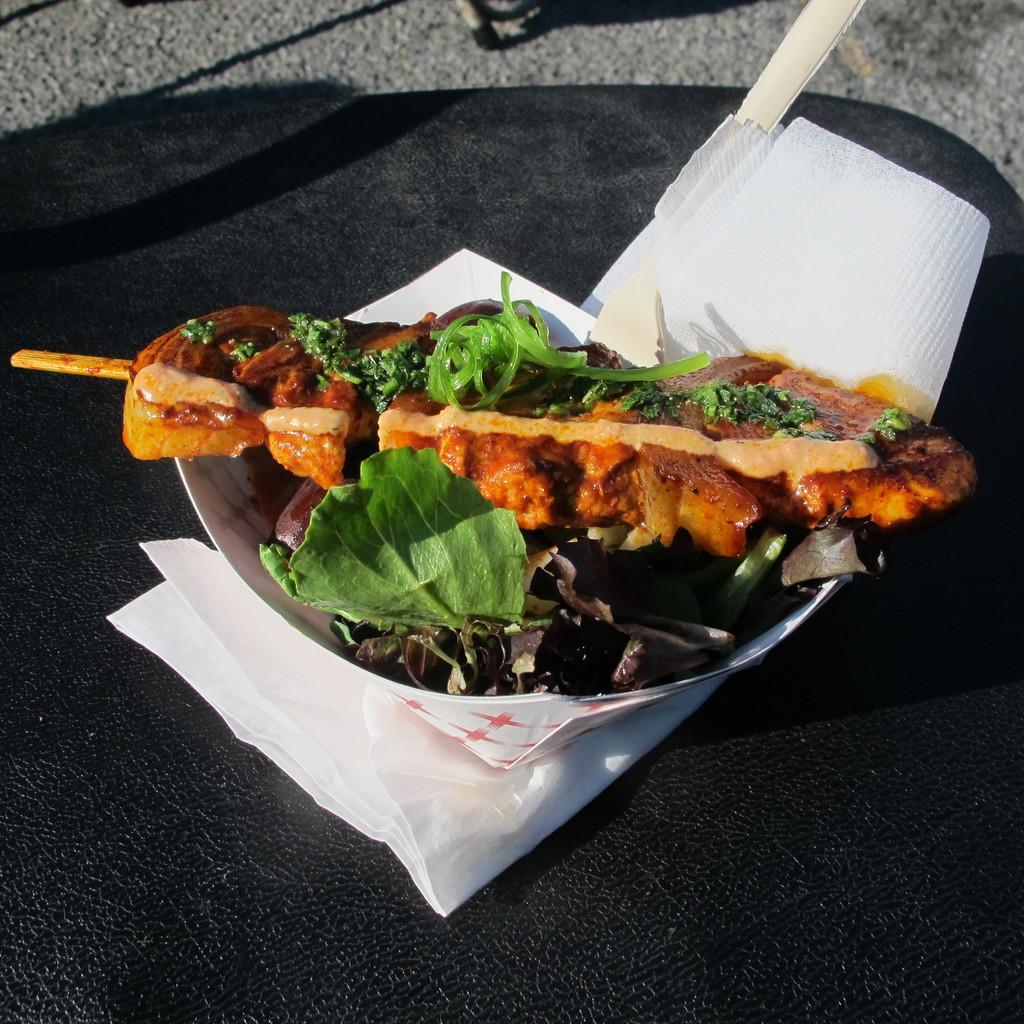Can you describe this image briefly? In this picture we can see food in the plate, and we can find tissue papers on the table. 